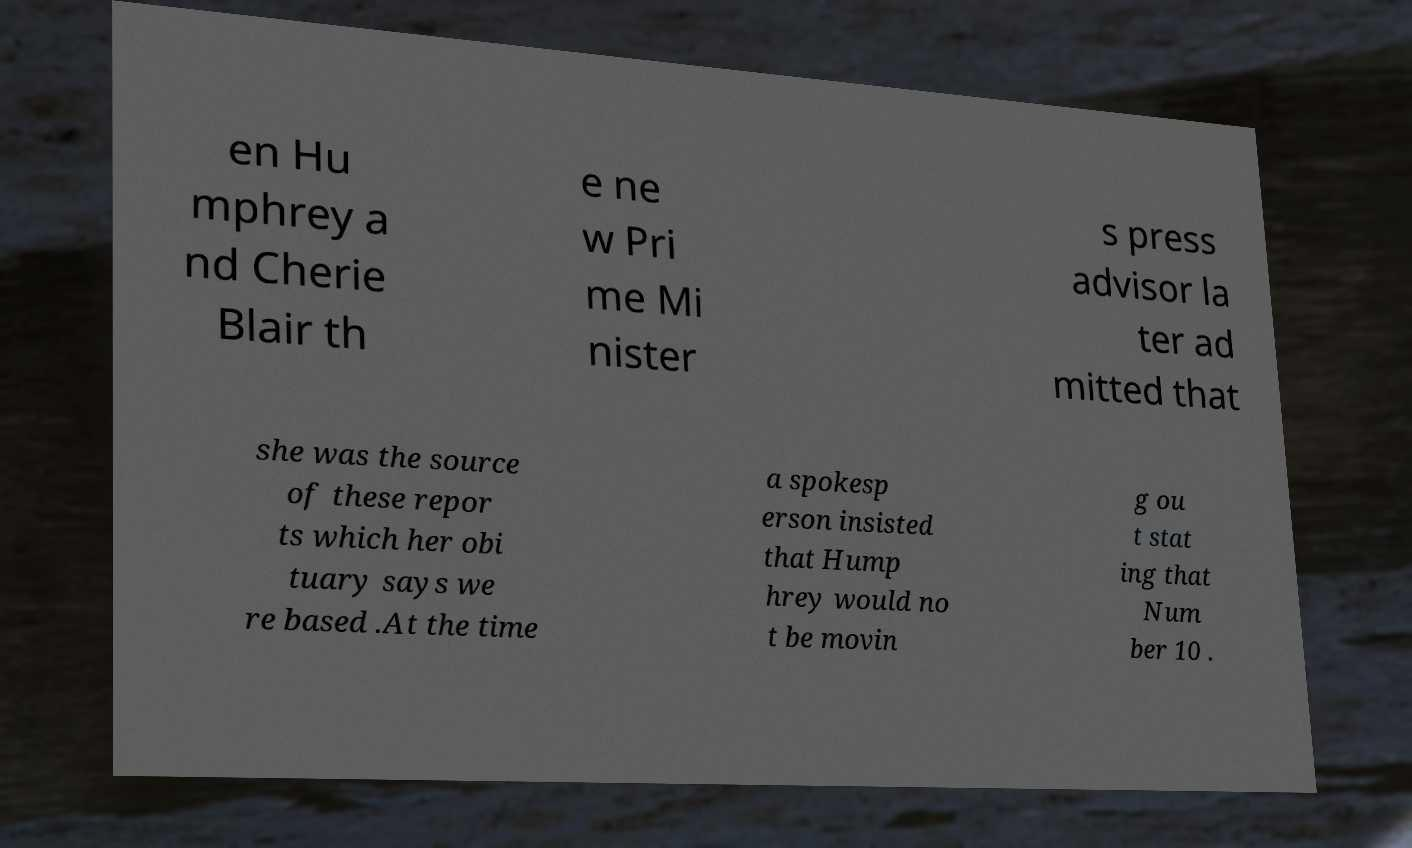What messages or text are displayed in this image? I need them in a readable, typed format. en Hu mphrey a nd Cherie Blair th e ne w Pri me Mi nister s press advisor la ter ad mitted that she was the source of these repor ts which her obi tuary says we re based .At the time a spokesp erson insisted that Hump hrey would no t be movin g ou t stat ing that Num ber 10 . 